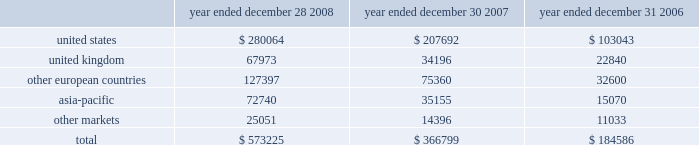Executive deferred compensation plan for the company 2019s executives and members of the board of directors , the company adopted the illumina , inc .
Deferred compensation plan ( the plan ) that became effective january 1 , 2008 .
Eligible participants can contribute up to 80% ( 80 % ) of their base salary and 100% ( 100 % ) of all other forms of compensation into the plan , including bonus , commission and director fees .
The company has agreed to credit the participants 2019 contributions with earnings that reflect the performance of certain independent investment funds .
On a discretionary basis , the company may also make employer contributions to participant accounts in any amount determined by the company .
The vesting schedules of employer contributions are at the sole discretion of the compensation committee .
However , all employer contributions shall become 100% ( 100 % ) vested upon the occurrence of the participant 2019s disability , death or retirement or a change in control of the company .
The benefits under this plan are unsecured .
Participants are generally eligible to receive payment of their vested benefit at the end of their elected deferral period or after termination of their employment with the company for any reason or at a later date to comply with the restrictions of section 409a .
As of december 28 , 2008 , no employer contributions were made to the plan .
In january 2008 , the company also established a rabbi trust for the benefit of its directors and executives under the plan .
In accordance with fasb interpretation ( fin ) no .
46 , consolidation of variable interest entities , an interpretation of arb no .
51 , and eitf 97-14 , accounting for deferred compensation arrangements where amounts earned are held in a rabbi trust and invested , the company has included the assets of the rabbi trust in its consolidated balance sheet since the trust 2019s inception .
As of december 28 , 2008 , the assets of the trust and liabilities of the company were $ 1.3 million .
The assets and liabilities are classified as other assets and accrued liabilities , respectively , on the company 2019s balance sheet as of december 28 , 2008 .
Changes in the values of the assets held by the rabbi trust accrue to the company .
14 .
Segment information , geographic data and significant customers during the first quarter of 2008 , the company reorganized its operating structure into a newly created life sciences business unit , which includes all products and services related to the research market , namely the beadarray , beadxpress and sequencing product lines .
The company also created a diagnostics business unit to focus on the emerging opportunity in molecular diagnostics .
For the year ended december 28 , 2008 , the company had limited activity related to the diagnostics business unit , and operating results were reported on an aggregate basis to the chief operating decision maker of the company , the chief executive officer .
In accordance with sfas no .
131 , disclosures about segments of an enterprise and related information , the company operated in one reportable segment for the year ended december 28 , 2008 .
The company had revenue in the following regions for the years ended december 28 , 2008 , december 30 , 2007 and december 31 , 2006 ( in thousands ) : year ended december 28 , year ended december 30 , year ended december 31 .
Net revenues are attributable to geographic areas based on the region of destination .
Illumina , inc .
Notes to consolidated financial statements 2014 ( continued ) .
What percentage of total revenue in 2008 came from the asia-pacific region? 
Computations: (72740 / 573225)
Answer: 0.1269. 